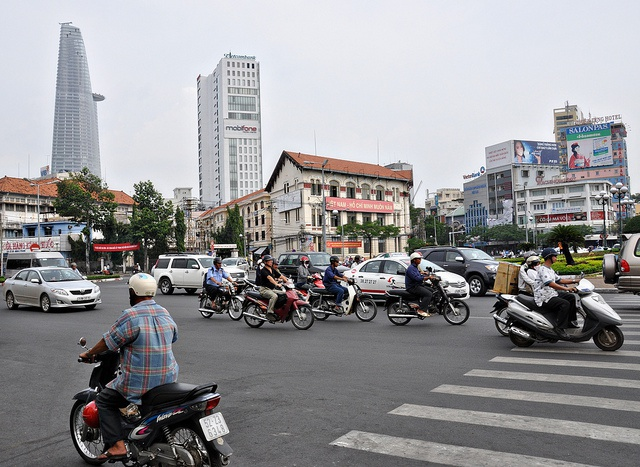Describe the objects in this image and their specific colors. I can see motorcycle in lavender, black, gray, darkgray, and lightgray tones, people in lavender, black, gray, darkgray, and blue tones, motorcycle in lavender, black, lightgray, gray, and darkgray tones, car in lavender, lightgray, gray, darkgray, and black tones, and people in lavender, black, darkgray, lightgray, and gray tones in this image. 